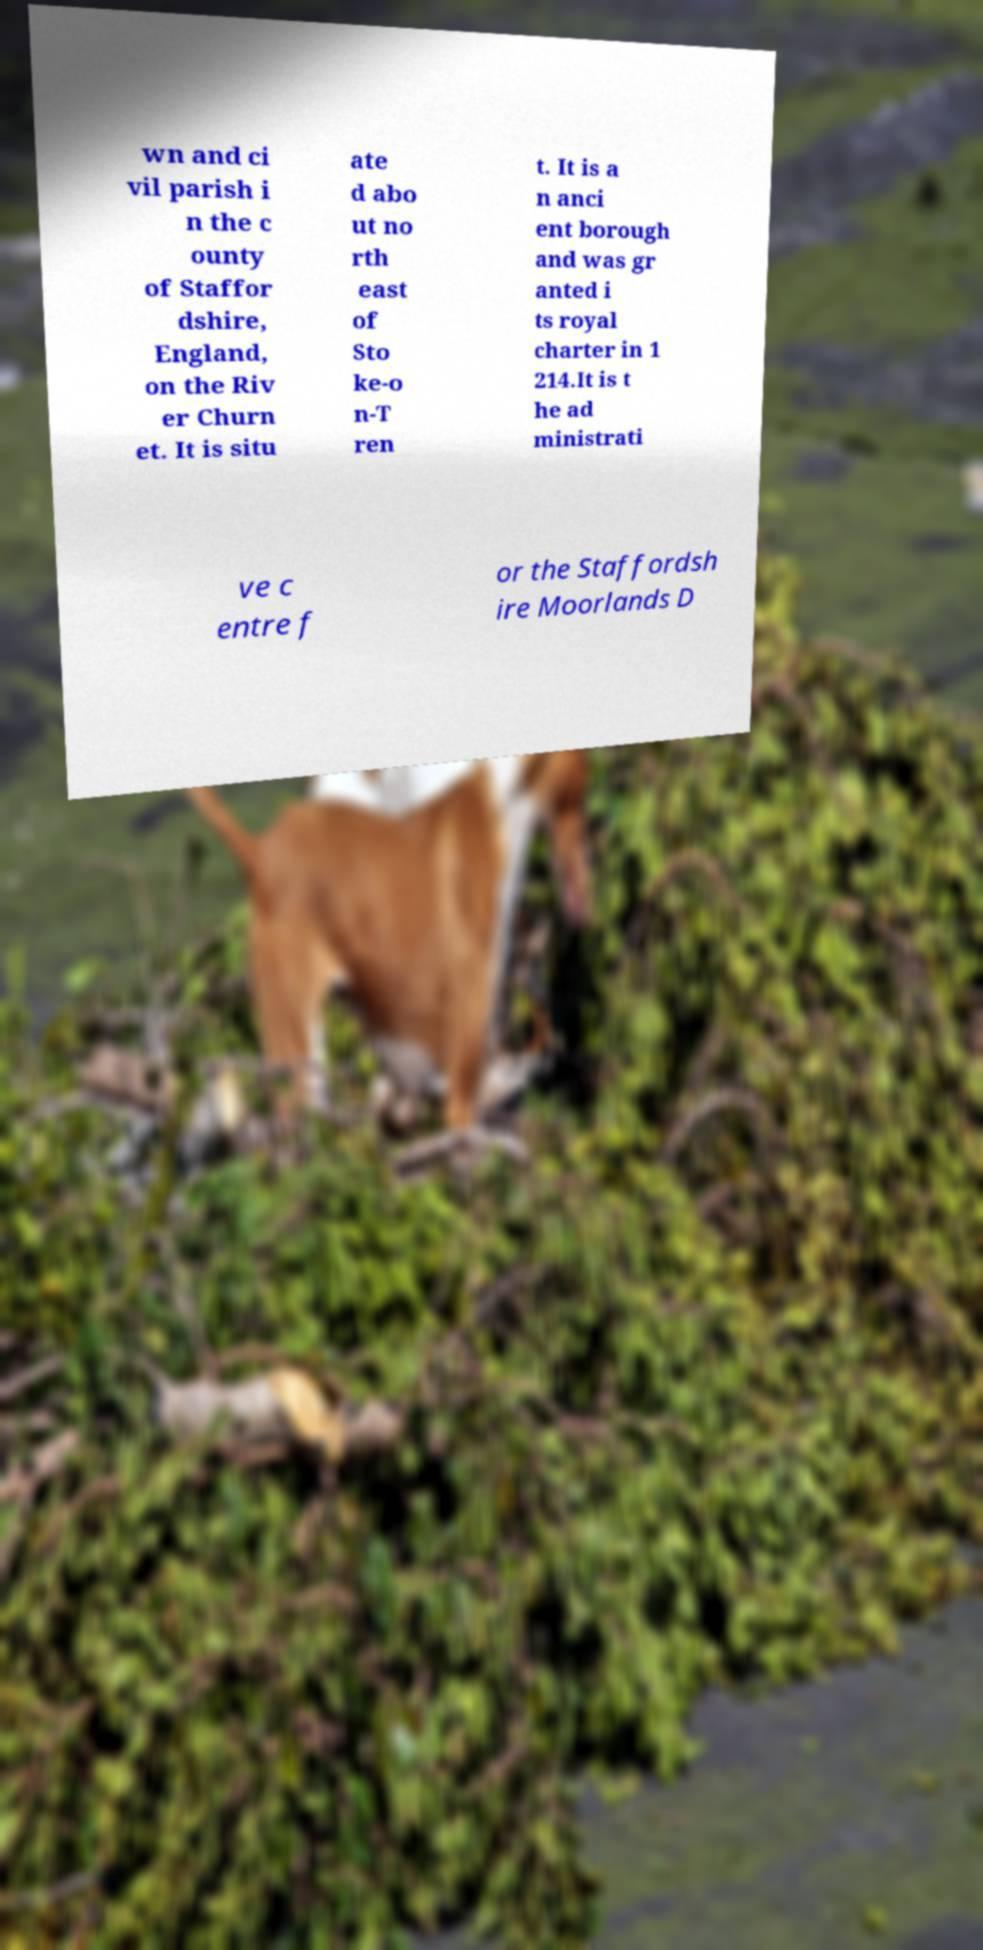What messages or text are displayed in this image? I need them in a readable, typed format. wn and ci vil parish i n the c ounty of Staffor dshire, England, on the Riv er Churn et. It is situ ate d abo ut no rth east of Sto ke-o n-T ren t. It is a n anci ent borough and was gr anted i ts royal charter in 1 214.It is t he ad ministrati ve c entre f or the Staffordsh ire Moorlands D 